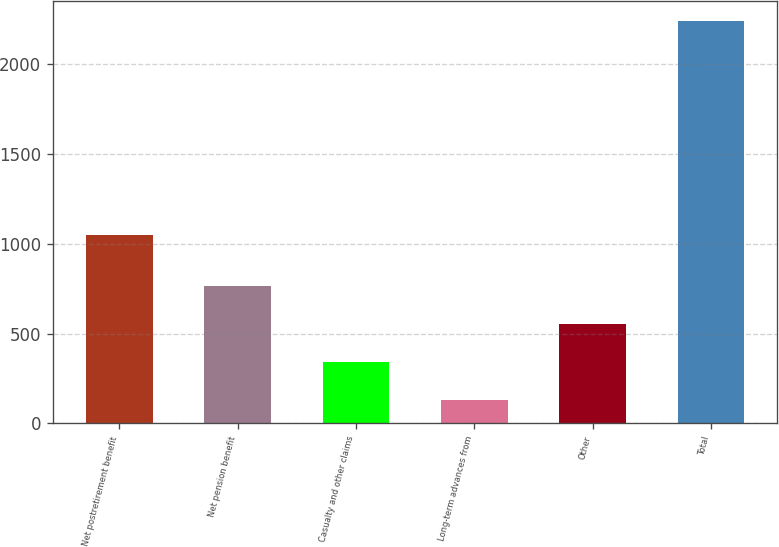Convert chart to OTSL. <chart><loc_0><loc_0><loc_500><loc_500><bar_chart><fcel>Net postretirement benefit<fcel>Net pension benefit<fcel>Casualty and other claims<fcel>Long-term advances from<fcel>Other<fcel>Total<nl><fcel>1049<fcel>764.2<fcel>343.4<fcel>133<fcel>553.8<fcel>2237<nl></chart> 